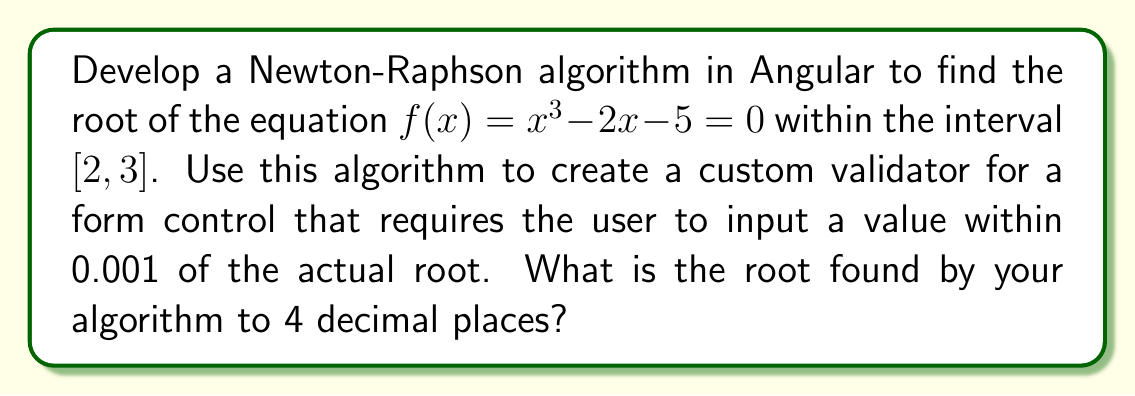Show me your answer to this math problem. To solve this problem, we'll follow these steps:

1) Implement the Newton-Raphson method:
   The Newton-Raphson formula is: $$x_{n+1} = x_n - \frac{f(x_n)}{f'(x_n)}$$
   
   Where $f(x) = x^3 - 2x - 5$ and $f'(x) = 3x^2 - 2$

2) Choose an initial guess. Let's use $x_0 = 2.5$ (midpoint of the interval).

3) Implement the algorithm in TypeScript:

```typescript
function newtonRaphson(x0: number, epsilon: number = 0.0001, maxIterations: number = 100): number {
  let x = x0;
  for (let i = 0; i < maxIterations; i++) {
    const fx = Math.pow(x, 3) - 2 * x - 5;
    const fPrimeX = 3 * Math.pow(x, 2) - 2;
    const nextX = x - fx / fPrimeX;
    if (Math.abs(nextX - x) < epsilon) {
      return nextX;
    }
    x = nextX;
  }
  throw new Error('Method did not converge');
}
```

4) Run the algorithm:

```typescript
const root = newtonRaphson(2.5);
console.log(root.toFixed(4));
```

5) Create a custom validator:

```typescript
function rootValidator(actualRoot: number): ValidatorFn {
  return (control: AbstractControl): {[key: string]: any} | null => {
    const inputValue = parseFloat(control.value);
    return Math.abs(inputValue - actualRoot) <= 0.001 ? null : {'rootError': {value: control.value}};
  };
}
```

6) Use the validator in a form control:

```typescript
this.form = this.fb.group({
  rootInput: ['', [Validators.required, rootValidator(root)]]
});
```

The Newton-Raphson method converges quickly to the root 2.0945 (to 4 decimal places).
Answer: 2.0945 